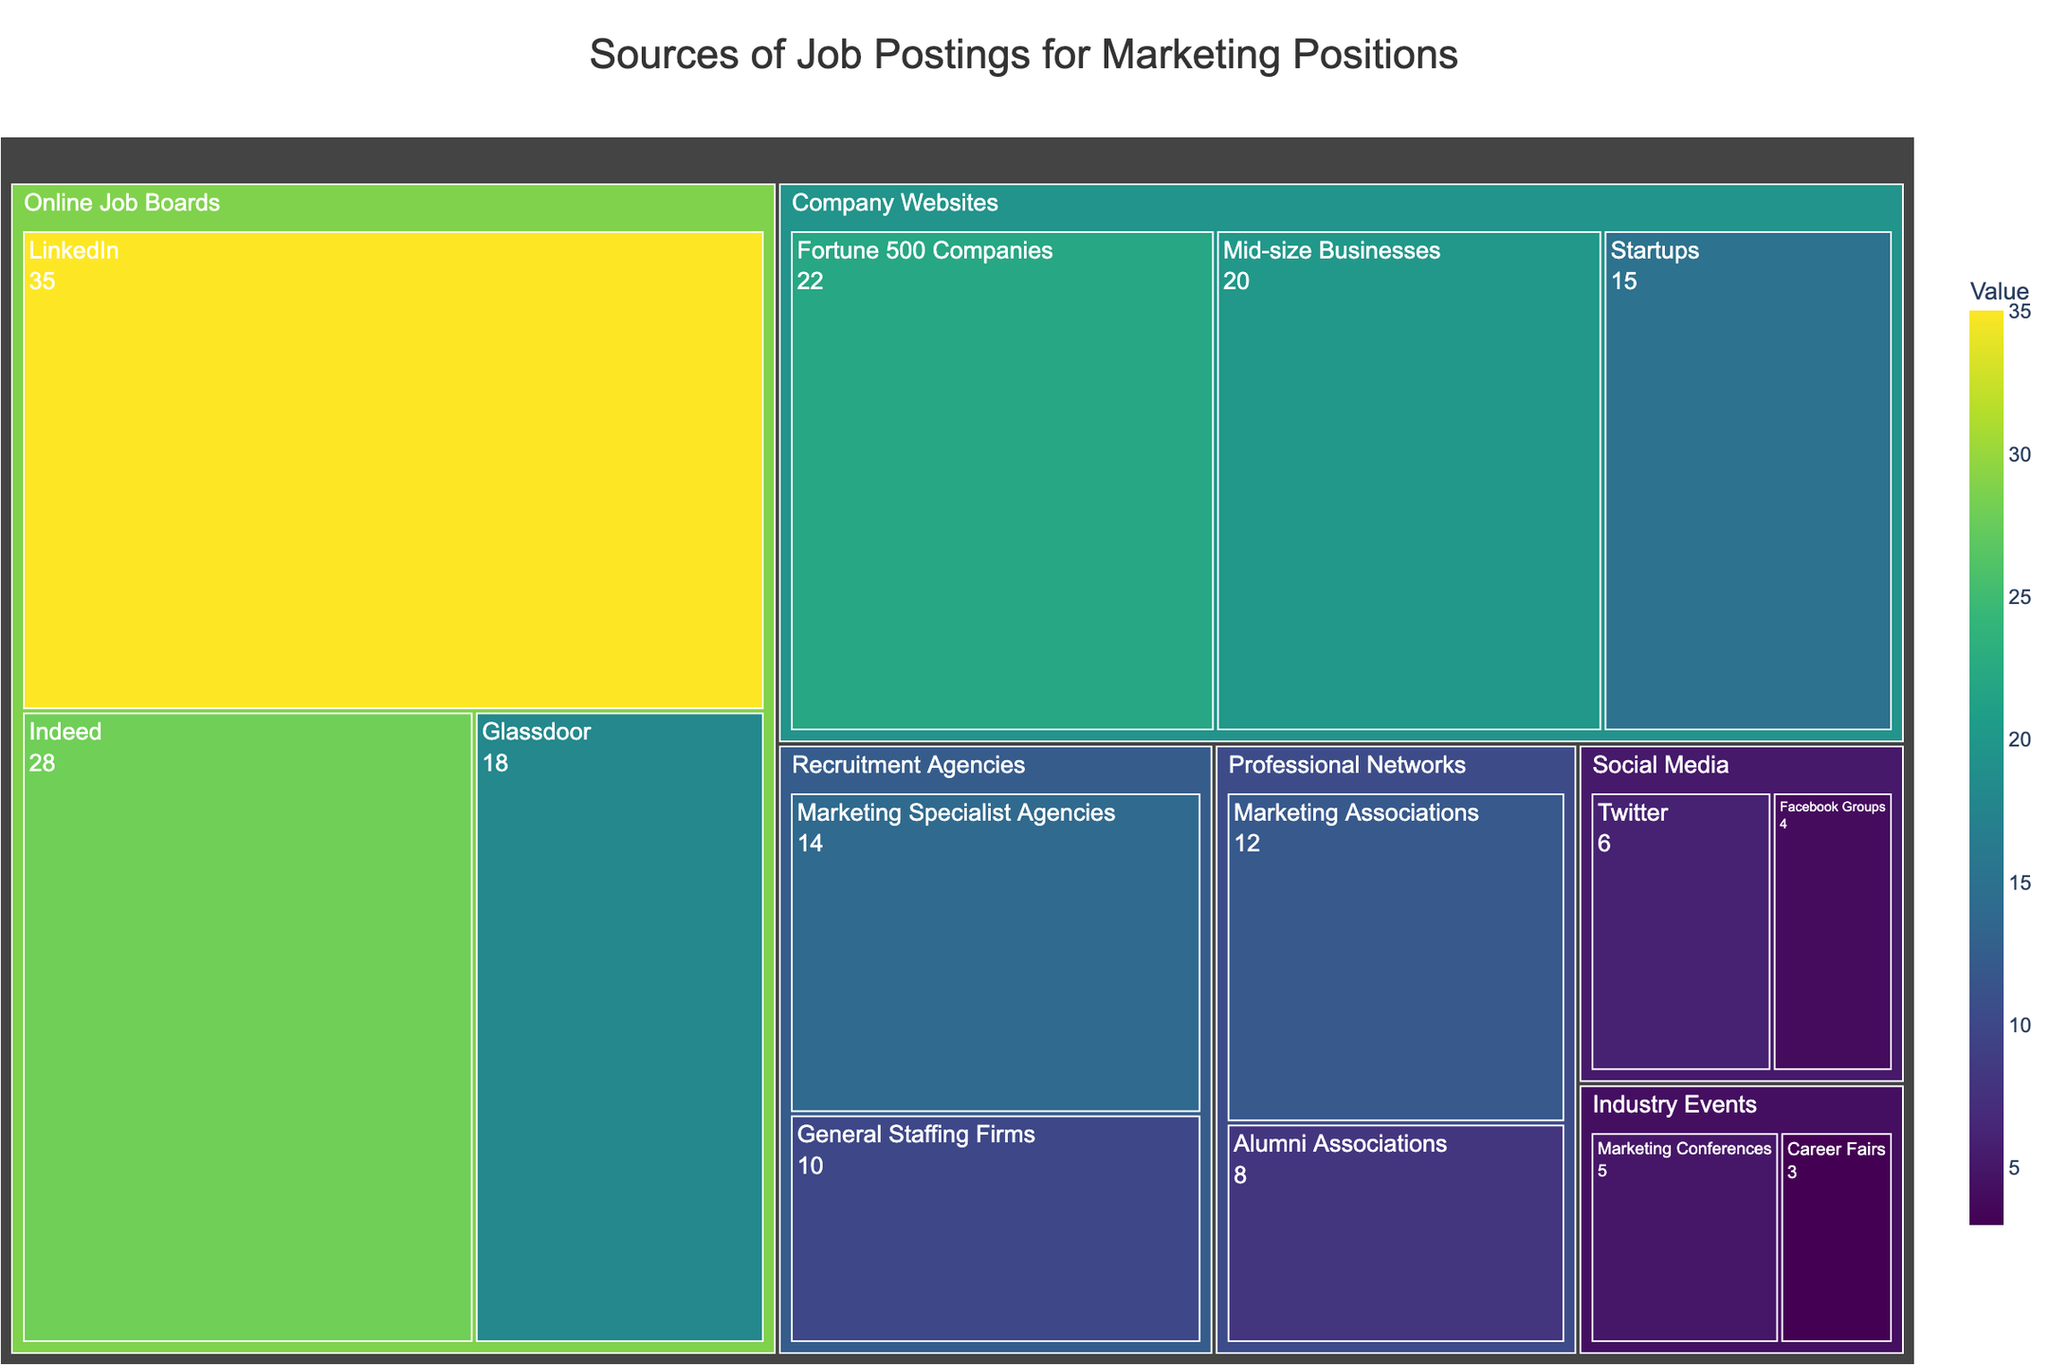What's the title of the treemap? The title is always placed at the top of the figure, representing the overall subject the image is depicting. It's useful to identify the focus of the visualization.
Answer: Sources of Job Postings for Marketing Positions Which subcategory under 'Online Job Boards' has the highest value? Under 'Online Job Boards', each subcategory (LinkedIn, Indeed, Glassdoor) will have a labeled value. By comparing these labeled values, you can see that LinkedIn has the highest with a value of 35.
Answer: LinkedIn What is the combined value of job postings from 'Company Websites'? Add the values of all the subcategories under 'Company Websites' (Fortune 500 Companies, Startups, Mid-size Businesses). 22 (Fortune 500 Companies) + 15 (Startups) + 20 (Mid-size Businesses) = 57.
Answer: 57 How does the total value of 'Social Media' compare to 'Industry Events'? Calculate the sum of values for 'Social Media' and 'Industry Events'. ‘Social Media’: 6 (Twitter) + 4 (Facebook Groups) = 10. ‘Industry Events’: 5 (Marketing Conferences) + 3 (Career Fairs) = 8. Then compare the sums.
Answer: Social Media is greater In which category is the 'Marketing Specialist Agencies' subcategory? Identify the parent category of the 'Marketing Specialist Agencies' subcategory by examining its placement in the treemap hierarchy. 'Marketing Specialist Agencies' falls under 'Recruitment Agencies'.
Answer: Recruitment Agencies What is the total number of subcategories in the treemap? Count the number of individual subcategories listed under all parent categories: Online Job Boards (3), Company Websites (3), Professional Networks (2), Recruitment Agencies (2), Social Media (2), Industry Events (2). 3 + 3 + 2 + 2 + 2 + 2 = 14.
Answer: 14 Which category has the least total value? Sum the values for each category and compare the totals. The sums are: 
- Online Job Boards: 81
- Company Websites: 57
- Professional Networks: 20
- Recruitment Agencies: 24
- Social Media: 10
- Industry Events: 8.
'Industry Events' has the least total value.
Answer: Industry Events What's the average value of postings from 'Recruitment Agencies'? Sum the values of subcategories under 'Recruitment Agencies' and divide by the number of subcategories. (14 [Marketing Specialist Agencies] + 10 [General Staffing Firms]) / 2 = 24 / 2 = 12.
Answer: 12 How does the value for 'Marketing Conferences' compare with 'Facebook Groups'? Compare the number directly; 'Marketing Conferences' has a value of 5, while 'Facebook Groups' has a value of 4.
Answer: Marketing Conferences is greater What percentage of the total value does 'LinkedIn' represent? Find the total sum of all values: 35 + 28 + 18 + 22 + 15 + 20 + 8 + 12 + 14 + 10 + 6 + 4 + 5 + 3 = 200. Then, calculate the percentage: (35/200) * 100 = 17.5%.
Answer: 17.5% 